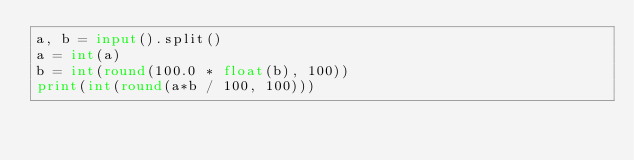Convert code to text. <code><loc_0><loc_0><loc_500><loc_500><_Python_>a, b = input().split()
a = int(a)
b = int(round(100.0 * float(b), 100))
print(int(round(a*b / 100, 100)))
</code> 